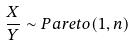Convert formula to latex. <formula><loc_0><loc_0><loc_500><loc_500>\frac { X } { Y } \sim P a r e t o ( 1 , n )</formula> 